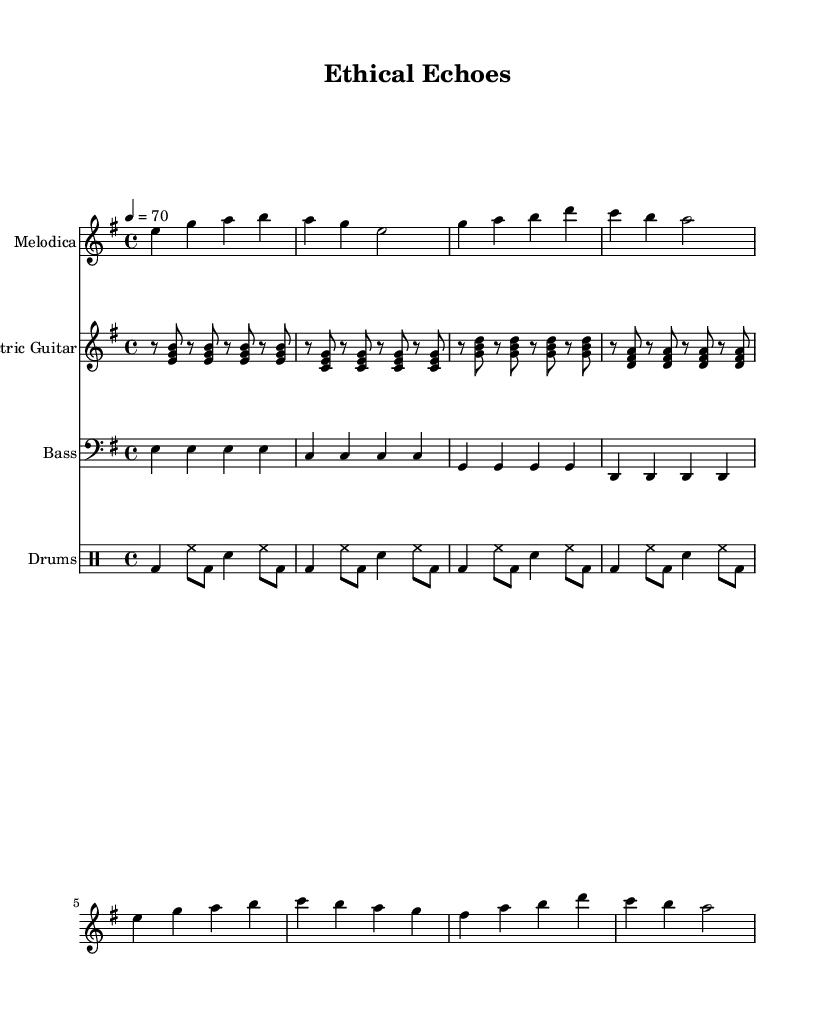What is the key signature of this music? The key signature shows two sharps (F# and C#), indicating that this piece is in the key of E minor.
Answer: E minor What is the time signature of this music? Looking at the beginning of the score, the time signature is displayed as 4/4, meaning there are four beats per measure.
Answer: 4/4 What is the tempo marking of this music? The tempo marking indicates a speed of 70 beats per minute, as noted beside the tempo symbol.
Answer: 70 How many measures are there in the piece? Counting the measures from the score, we observe there are a total of 16 measures present in the music.
Answer: 16 Which instrument is featured in the melodic line? The melodic line is played by the melodica, as specified in the instrument names at the start of the staff.
Answer: Melodica What is the role of the bass guitar in this piece? The bass guitar provides rhythmic support and harmonic foundation with consistent quarter notes throughout the measures.
Answer: Harmonic foundation What characteristic elements of reggae are present in this piece? The piece features offbeat guitar strumming and a laid-back rhythm typical of reggae, identifiable in the chord changes and drum patterns.
Answer: Offbeat guitar strumming 